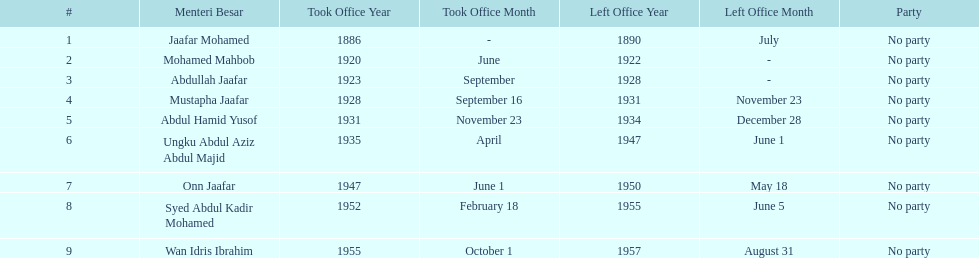Who spend the most amount of time in office? Ungku Abdul Aziz Abdul Majid. 